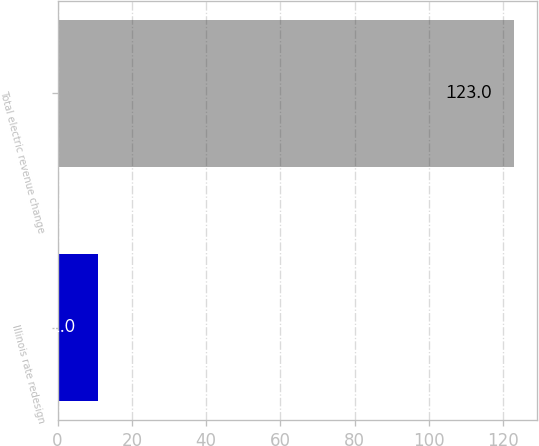Convert chart. <chart><loc_0><loc_0><loc_500><loc_500><bar_chart><fcel>Illinois rate redesign<fcel>Total electric revenue change<nl><fcel>11<fcel>123<nl></chart> 